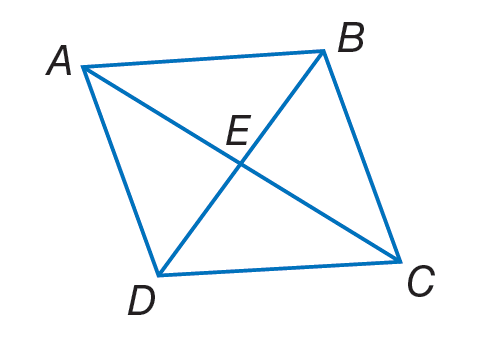Answer the mathemtical geometry problem and directly provide the correct option letter.
Question: A B C D is a rhombus. If E B = 9, A B = 12 and m \angle A B D = 55. Find C E.
Choices: A: \sqrt { 63 } B: \sqrt { 70 } C: 9 D: 12 A 